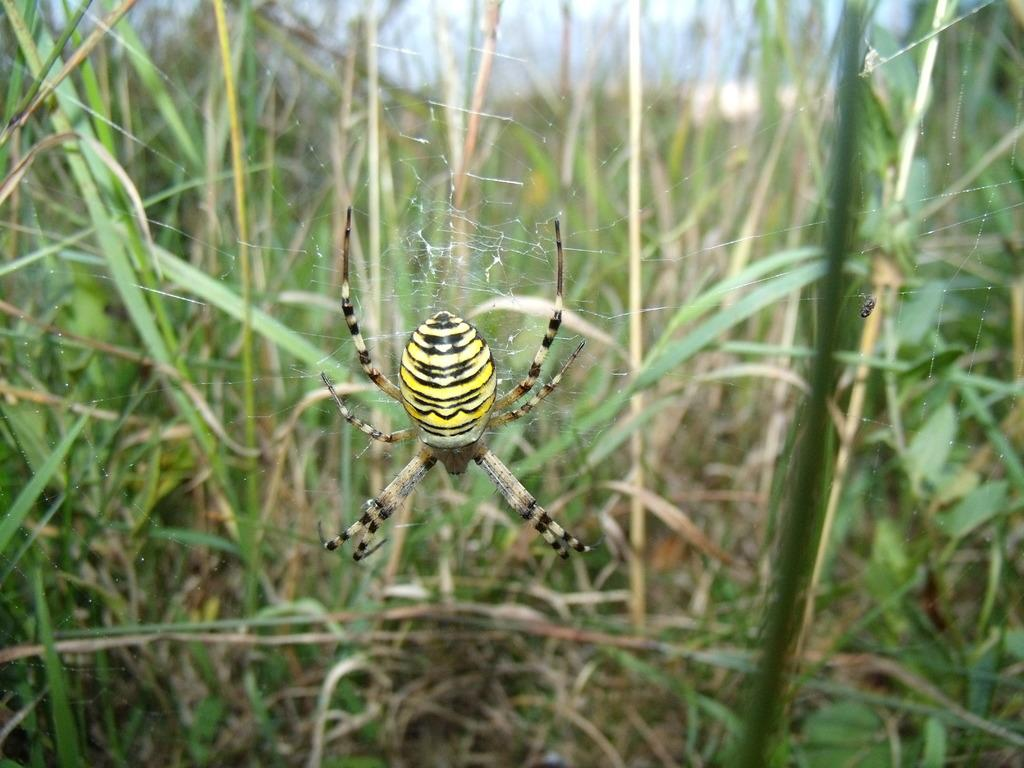What is the main subject of the image? There is a spider in the image. Where is the spider located? The spider is on a web. What else can be seen in the image besides the spider? There are plants visible in the image. What is visible in the background of the image? The sky is visible in the image. What statement does the woman make about the spider in the image? There is no woman present in the image, so no statement can be attributed to her. 